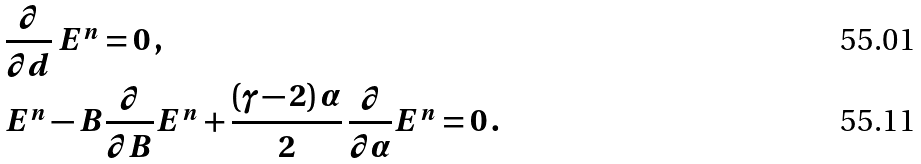<formula> <loc_0><loc_0><loc_500><loc_500>& \frac { \partial } { \partial d } \, E ^ { n } = 0 \, , \\ & E ^ { n } - B \frac { \partial } { \partial B } E ^ { n } + \frac { ( \gamma - 2 ) \, \alpha } { 2 } \, \frac { \partial } { \partial \alpha } E ^ { n } = 0 \, .</formula> 